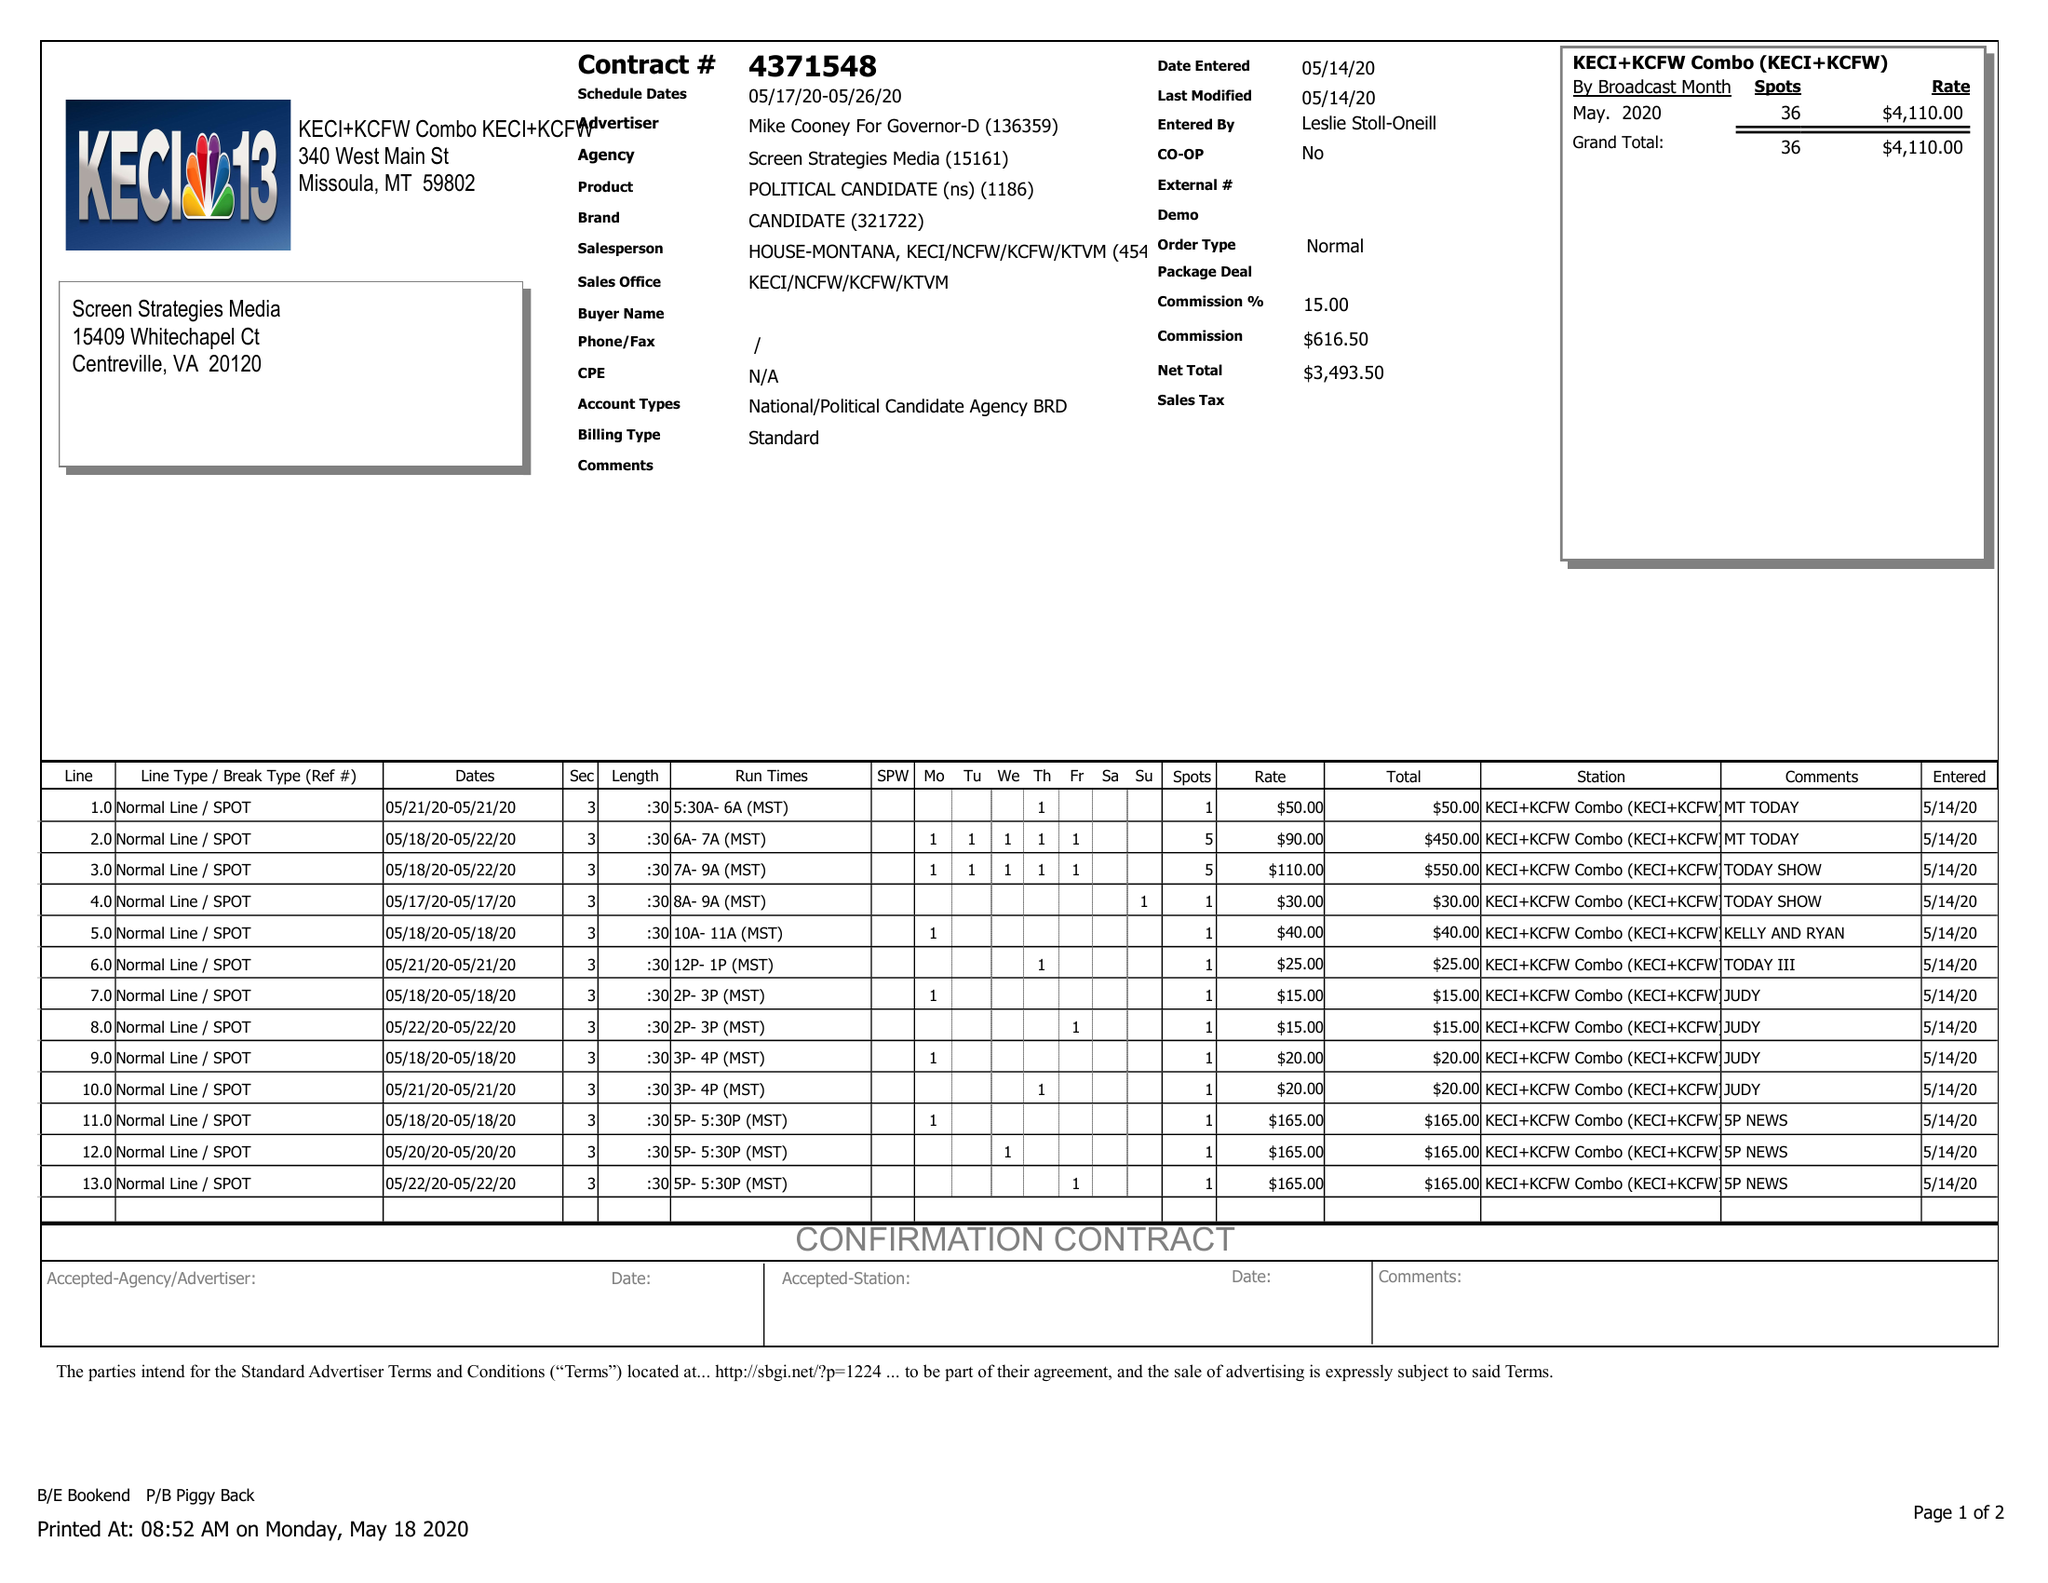What is the value for the flight_to?
Answer the question using a single word or phrase. 05/26/20 